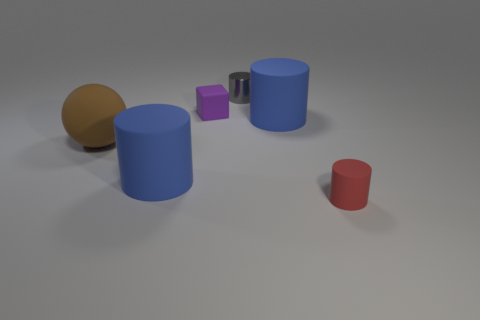What number of objects are either small purple matte cylinders or big rubber things that are right of the purple block?
Offer a terse response. 1. There is a tiny thing that is on the right side of the rubber cube and to the left of the small red cylinder; what shape is it?
Keep it short and to the point. Cylinder. There is a small cylinder that is behind the big cylinder that is on the left side of the purple matte object; what is its material?
Make the answer very short. Metal. Are the small purple cube behind the large brown matte ball and the small gray object made of the same material?
Offer a terse response. No. There is a object behind the matte cube; how big is it?
Your response must be concise. Small. Is there a rubber object to the right of the large blue matte cylinder to the left of the gray metallic cylinder?
Your answer should be very brief. Yes. Does the big matte cylinder in front of the brown ball have the same color as the big cylinder on the right side of the small gray object?
Your answer should be compact. Yes. The small cube is what color?
Make the answer very short. Purple. What is the color of the matte thing that is both in front of the ball and on the left side of the cube?
Your response must be concise. Blue. There is a blue cylinder left of the gray cylinder; does it have the same size as the brown rubber sphere?
Your response must be concise. Yes. 